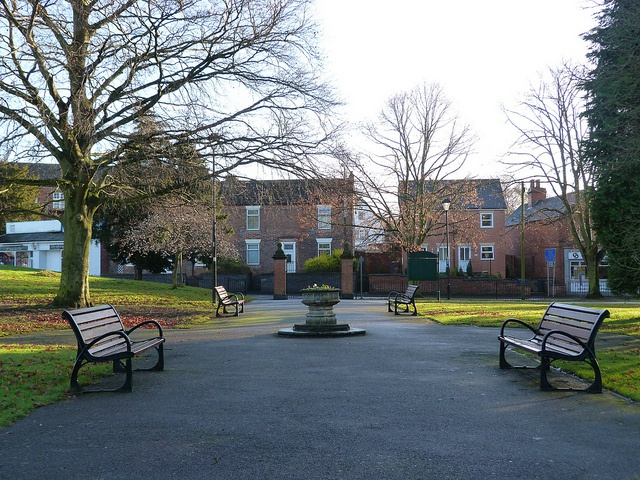Describe the objects in this image and their specific colors. I can see bench in black, gray, and darkgray tones, bench in black, darkgray, gray, and darkgreen tones, potted plant in black, gray, purple, and darkgreen tones, bench in black, gray, darkgray, and darkgreen tones, and bench in black, gray, white, and darkgreen tones in this image. 